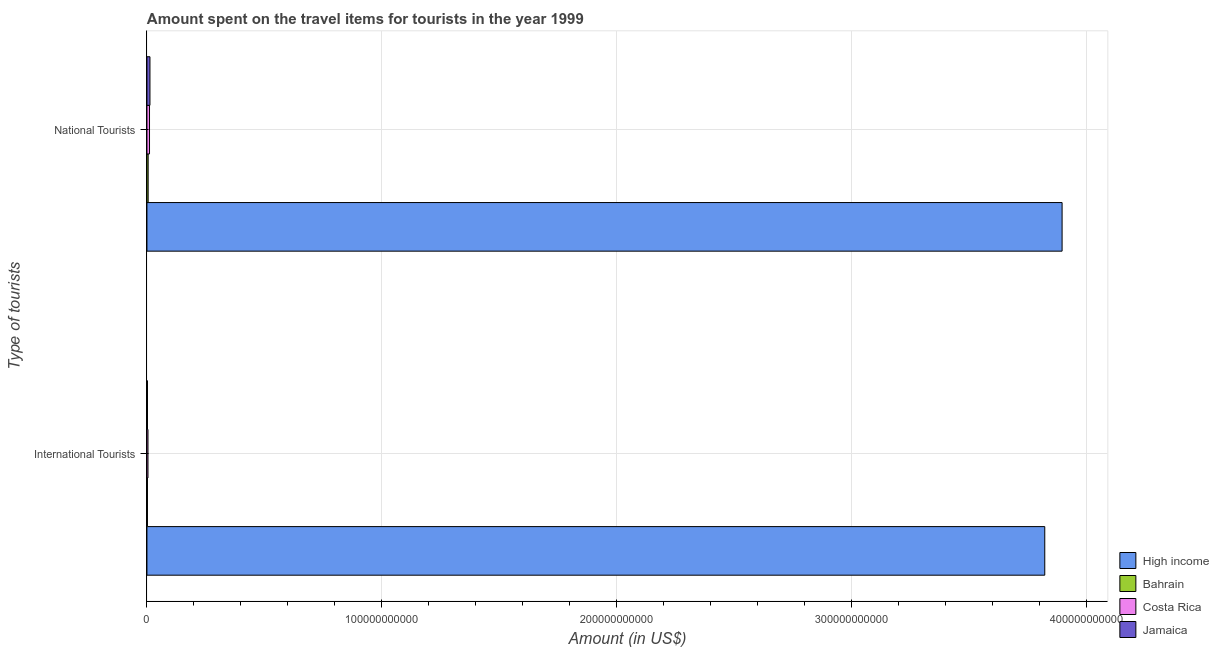How many groups of bars are there?
Keep it short and to the point. 2. How many bars are there on the 1st tick from the bottom?
Your answer should be compact. 4. What is the label of the 1st group of bars from the top?
Offer a very short reply. National Tourists. What is the amount spent on travel items of national tourists in Costa Rica?
Your response must be concise. 1.10e+09. Across all countries, what is the maximum amount spent on travel items of international tourists?
Provide a short and direct response. 3.82e+11. Across all countries, what is the minimum amount spent on travel items of national tourists?
Your answer should be compact. 5.18e+08. In which country was the amount spent on travel items of national tourists maximum?
Your response must be concise. High income. In which country was the amount spent on travel items of national tourists minimum?
Your response must be concise. Bahrain. What is the total amount spent on travel items of international tourists in the graph?
Provide a short and direct response. 3.83e+11. What is the difference between the amount spent on travel items of national tourists in Jamaica and that in Costa Rica?
Ensure brevity in your answer.  1.82e+08. What is the difference between the amount spent on travel items of international tourists in High income and the amount spent on travel items of national tourists in Costa Rica?
Your answer should be very brief. 3.81e+11. What is the average amount spent on travel items of international tourists per country?
Ensure brevity in your answer.  9.58e+1. What is the difference between the amount spent on travel items of national tourists and amount spent on travel items of international tourists in Jamaica?
Your answer should be very brief. 1.05e+09. In how many countries, is the amount spent on travel items of international tourists greater than 100000000000 US$?
Provide a succinct answer. 1. What is the ratio of the amount spent on travel items of international tourists in Jamaica to that in Costa Rica?
Your answer should be very brief. 0.51. What does the 3rd bar from the top in National Tourists represents?
Offer a very short reply. Bahrain. What does the 1st bar from the bottom in International Tourists represents?
Offer a very short reply. High income. How many bars are there?
Make the answer very short. 8. How many countries are there in the graph?
Ensure brevity in your answer.  4. What is the difference between two consecutive major ticks on the X-axis?
Provide a succinct answer. 1.00e+11. Does the graph contain grids?
Ensure brevity in your answer.  Yes. Where does the legend appear in the graph?
Offer a very short reply. Bottom right. How many legend labels are there?
Ensure brevity in your answer.  4. What is the title of the graph?
Your response must be concise. Amount spent on the travel items for tourists in the year 1999. What is the label or title of the Y-axis?
Make the answer very short. Type of tourists. What is the Amount (in US$) in High income in International Tourists?
Ensure brevity in your answer.  3.82e+11. What is the Amount (in US$) in Bahrain in International Tourists?
Keep it short and to the point. 2.12e+08. What is the Amount (in US$) of Costa Rica in International Tourists?
Offer a terse response. 4.47e+08. What is the Amount (in US$) in Jamaica in International Tourists?
Offer a terse response. 2.27e+08. What is the Amount (in US$) of High income in National Tourists?
Make the answer very short. 3.90e+11. What is the Amount (in US$) in Bahrain in National Tourists?
Your answer should be very brief. 5.18e+08. What is the Amount (in US$) of Costa Rica in National Tourists?
Provide a short and direct response. 1.10e+09. What is the Amount (in US$) in Jamaica in National Tourists?
Offer a very short reply. 1.28e+09. Across all Type of tourists, what is the maximum Amount (in US$) of High income?
Your response must be concise. 3.90e+11. Across all Type of tourists, what is the maximum Amount (in US$) of Bahrain?
Provide a short and direct response. 5.18e+08. Across all Type of tourists, what is the maximum Amount (in US$) in Costa Rica?
Keep it short and to the point. 1.10e+09. Across all Type of tourists, what is the maximum Amount (in US$) of Jamaica?
Provide a succinct answer. 1.28e+09. Across all Type of tourists, what is the minimum Amount (in US$) in High income?
Keep it short and to the point. 3.82e+11. Across all Type of tourists, what is the minimum Amount (in US$) of Bahrain?
Provide a short and direct response. 2.12e+08. Across all Type of tourists, what is the minimum Amount (in US$) of Costa Rica?
Give a very brief answer. 4.47e+08. Across all Type of tourists, what is the minimum Amount (in US$) in Jamaica?
Give a very brief answer. 2.27e+08. What is the total Amount (in US$) in High income in the graph?
Offer a very short reply. 7.72e+11. What is the total Amount (in US$) in Bahrain in the graph?
Ensure brevity in your answer.  7.30e+08. What is the total Amount (in US$) in Costa Rica in the graph?
Ensure brevity in your answer.  1.54e+09. What is the total Amount (in US$) in Jamaica in the graph?
Ensure brevity in your answer.  1.51e+09. What is the difference between the Amount (in US$) in High income in International Tourists and that in National Tourists?
Provide a short and direct response. -7.38e+09. What is the difference between the Amount (in US$) of Bahrain in International Tourists and that in National Tourists?
Make the answer very short. -3.06e+08. What is the difference between the Amount (in US$) of Costa Rica in International Tourists and that in National Tourists?
Provide a succinct answer. -6.51e+08. What is the difference between the Amount (in US$) in Jamaica in International Tourists and that in National Tourists?
Offer a terse response. -1.05e+09. What is the difference between the Amount (in US$) of High income in International Tourists and the Amount (in US$) of Bahrain in National Tourists?
Keep it short and to the point. 3.82e+11. What is the difference between the Amount (in US$) in High income in International Tourists and the Amount (in US$) in Costa Rica in National Tourists?
Ensure brevity in your answer.  3.81e+11. What is the difference between the Amount (in US$) of High income in International Tourists and the Amount (in US$) of Jamaica in National Tourists?
Offer a terse response. 3.81e+11. What is the difference between the Amount (in US$) in Bahrain in International Tourists and the Amount (in US$) in Costa Rica in National Tourists?
Keep it short and to the point. -8.86e+08. What is the difference between the Amount (in US$) of Bahrain in International Tourists and the Amount (in US$) of Jamaica in National Tourists?
Your response must be concise. -1.07e+09. What is the difference between the Amount (in US$) of Costa Rica in International Tourists and the Amount (in US$) of Jamaica in National Tourists?
Your answer should be compact. -8.33e+08. What is the average Amount (in US$) of High income per Type of tourists?
Offer a terse response. 3.86e+11. What is the average Amount (in US$) in Bahrain per Type of tourists?
Your response must be concise. 3.65e+08. What is the average Amount (in US$) of Costa Rica per Type of tourists?
Provide a short and direct response. 7.72e+08. What is the average Amount (in US$) in Jamaica per Type of tourists?
Your answer should be very brief. 7.54e+08. What is the difference between the Amount (in US$) in High income and Amount (in US$) in Bahrain in International Tourists?
Provide a short and direct response. 3.82e+11. What is the difference between the Amount (in US$) in High income and Amount (in US$) in Costa Rica in International Tourists?
Your answer should be very brief. 3.82e+11. What is the difference between the Amount (in US$) in High income and Amount (in US$) in Jamaica in International Tourists?
Keep it short and to the point. 3.82e+11. What is the difference between the Amount (in US$) of Bahrain and Amount (in US$) of Costa Rica in International Tourists?
Keep it short and to the point. -2.35e+08. What is the difference between the Amount (in US$) in Bahrain and Amount (in US$) in Jamaica in International Tourists?
Ensure brevity in your answer.  -1.50e+07. What is the difference between the Amount (in US$) in Costa Rica and Amount (in US$) in Jamaica in International Tourists?
Your answer should be compact. 2.20e+08. What is the difference between the Amount (in US$) of High income and Amount (in US$) of Bahrain in National Tourists?
Offer a very short reply. 3.89e+11. What is the difference between the Amount (in US$) of High income and Amount (in US$) of Costa Rica in National Tourists?
Give a very brief answer. 3.88e+11. What is the difference between the Amount (in US$) in High income and Amount (in US$) in Jamaica in National Tourists?
Ensure brevity in your answer.  3.88e+11. What is the difference between the Amount (in US$) of Bahrain and Amount (in US$) of Costa Rica in National Tourists?
Ensure brevity in your answer.  -5.80e+08. What is the difference between the Amount (in US$) of Bahrain and Amount (in US$) of Jamaica in National Tourists?
Offer a terse response. -7.62e+08. What is the difference between the Amount (in US$) of Costa Rica and Amount (in US$) of Jamaica in National Tourists?
Make the answer very short. -1.82e+08. What is the ratio of the Amount (in US$) in High income in International Tourists to that in National Tourists?
Your answer should be compact. 0.98. What is the ratio of the Amount (in US$) of Bahrain in International Tourists to that in National Tourists?
Ensure brevity in your answer.  0.41. What is the ratio of the Amount (in US$) of Costa Rica in International Tourists to that in National Tourists?
Make the answer very short. 0.41. What is the ratio of the Amount (in US$) of Jamaica in International Tourists to that in National Tourists?
Your answer should be compact. 0.18. What is the difference between the highest and the second highest Amount (in US$) of High income?
Offer a very short reply. 7.38e+09. What is the difference between the highest and the second highest Amount (in US$) of Bahrain?
Offer a terse response. 3.06e+08. What is the difference between the highest and the second highest Amount (in US$) in Costa Rica?
Your answer should be very brief. 6.51e+08. What is the difference between the highest and the second highest Amount (in US$) of Jamaica?
Provide a short and direct response. 1.05e+09. What is the difference between the highest and the lowest Amount (in US$) of High income?
Offer a terse response. 7.38e+09. What is the difference between the highest and the lowest Amount (in US$) of Bahrain?
Your answer should be very brief. 3.06e+08. What is the difference between the highest and the lowest Amount (in US$) in Costa Rica?
Offer a terse response. 6.51e+08. What is the difference between the highest and the lowest Amount (in US$) in Jamaica?
Give a very brief answer. 1.05e+09. 